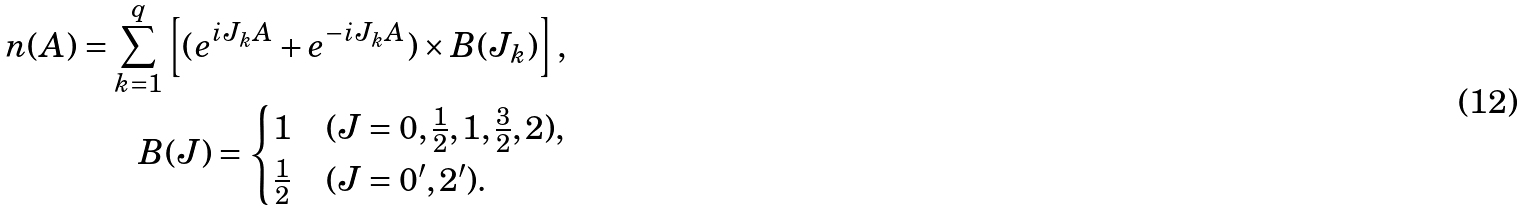Convert formula to latex. <formula><loc_0><loc_0><loc_500><loc_500>n ( A ) = \sum _ { k = 1 } ^ { q } \left [ ( e ^ { i J _ { k } A } + e ^ { - i J _ { k } A } ) \times B ( J _ { k } ) \right ] , \\ B ( J ) = \begin{cases} 1 & ( J = 0 , \frac { 1 } { 2 } , 1 , \frac { 3 } { 2 } , 2 ) , \\ \frac { 1 } { 2 } & ( J = 0 ^ { \prime } , 2 ^ { \prime } ) . \end{cases}</formula> 